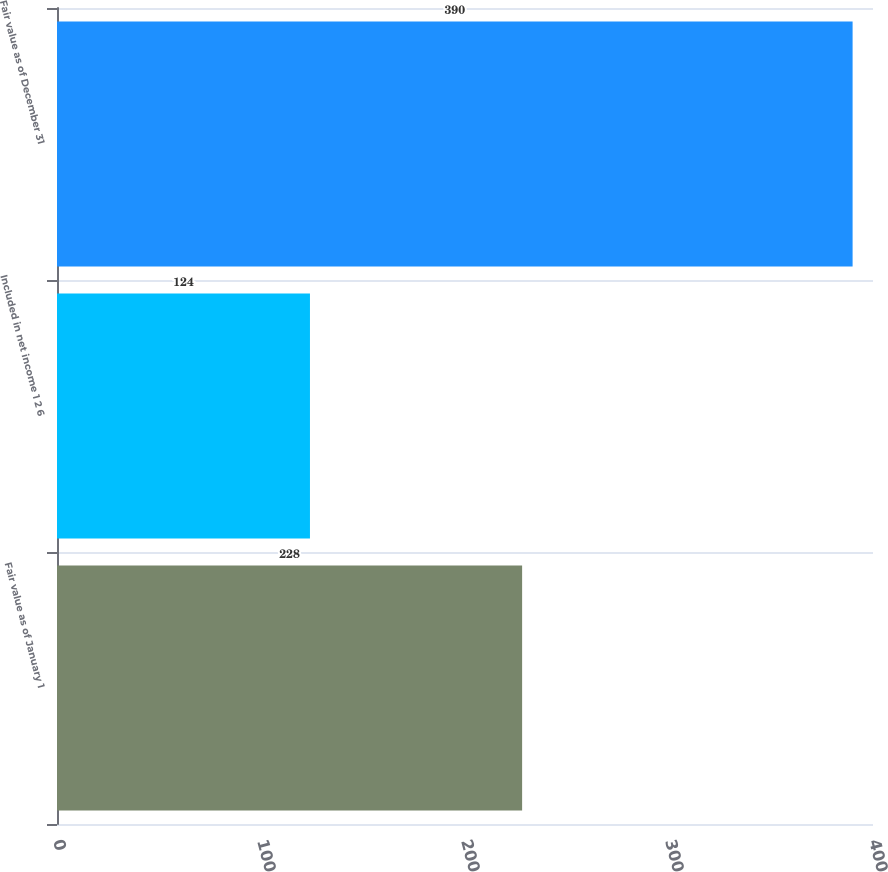<chart> <loc_0><loc_0><loc_500><loc_500><bar_chart><fcel>Fair value as of January 1<fcel>Included in net income 1 2 6<fcel>Fair value as of December 31<nl><fcel>228<fcel>124<fcel>390<nl></chart> 